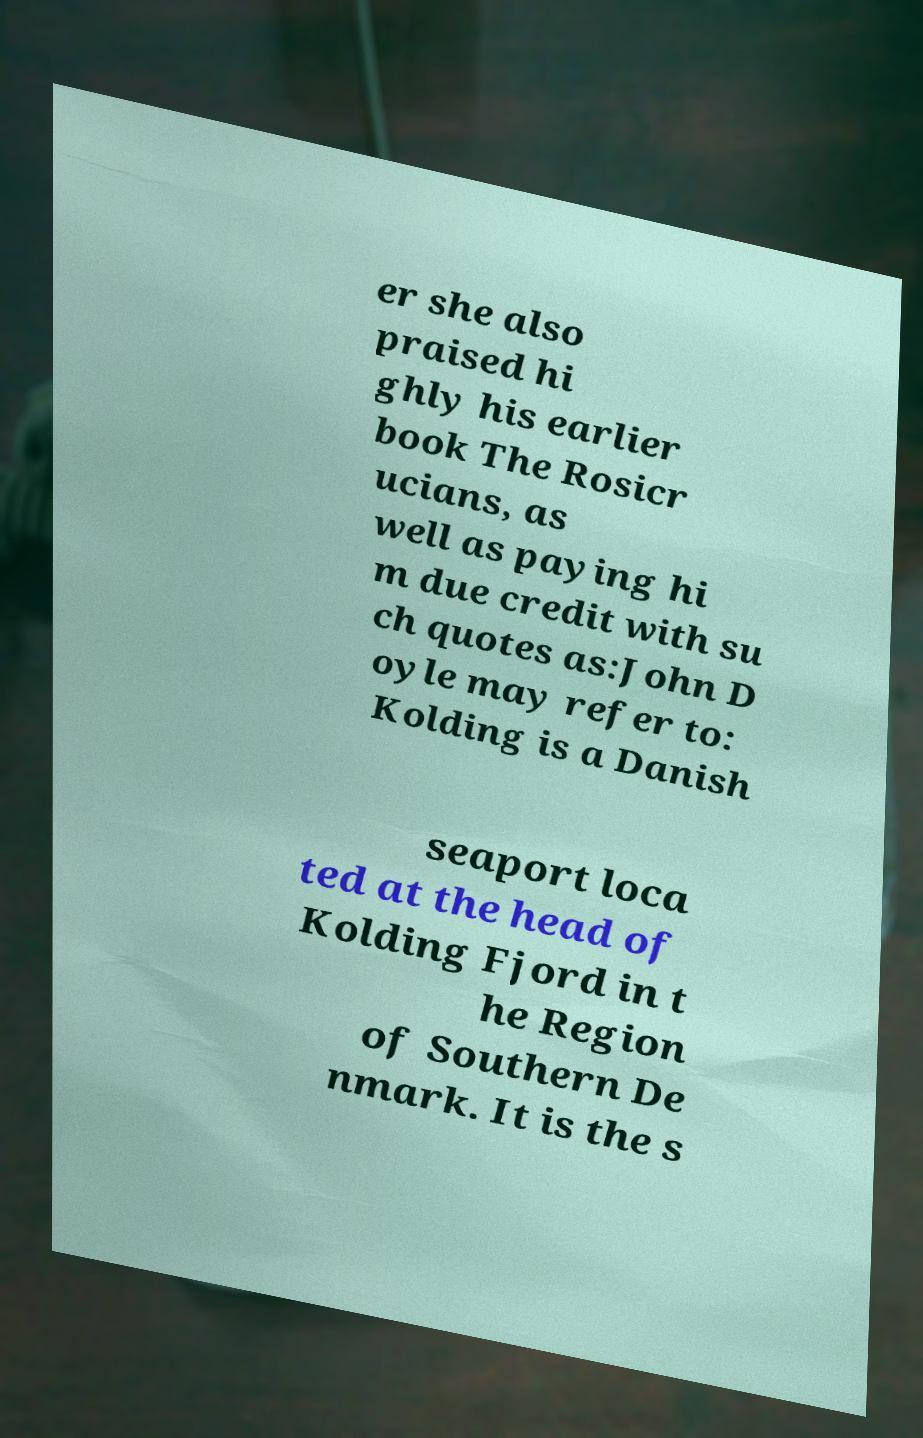I need the written content from this picture converted into text. Can you do that? er she also praised hi ghly his earlier book The Rosicr ucians, as well as paying hi m due credit with su ch quotes as:John D oyle may refer to: Kolding is a Danish seaport loca ted at the head of Kolding Fjord in t he Region of Southern De nmark. It is the s 